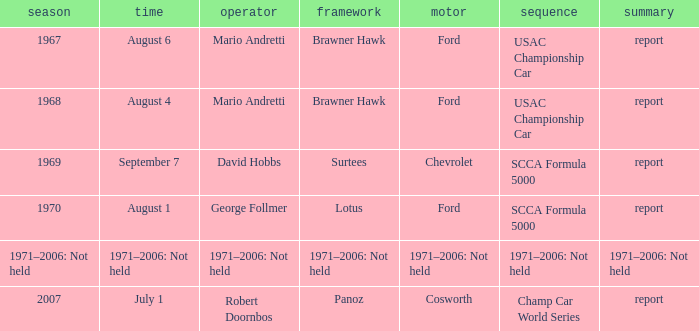Which engine is responsible for the USAC Championship Car? Ford, Ford. 